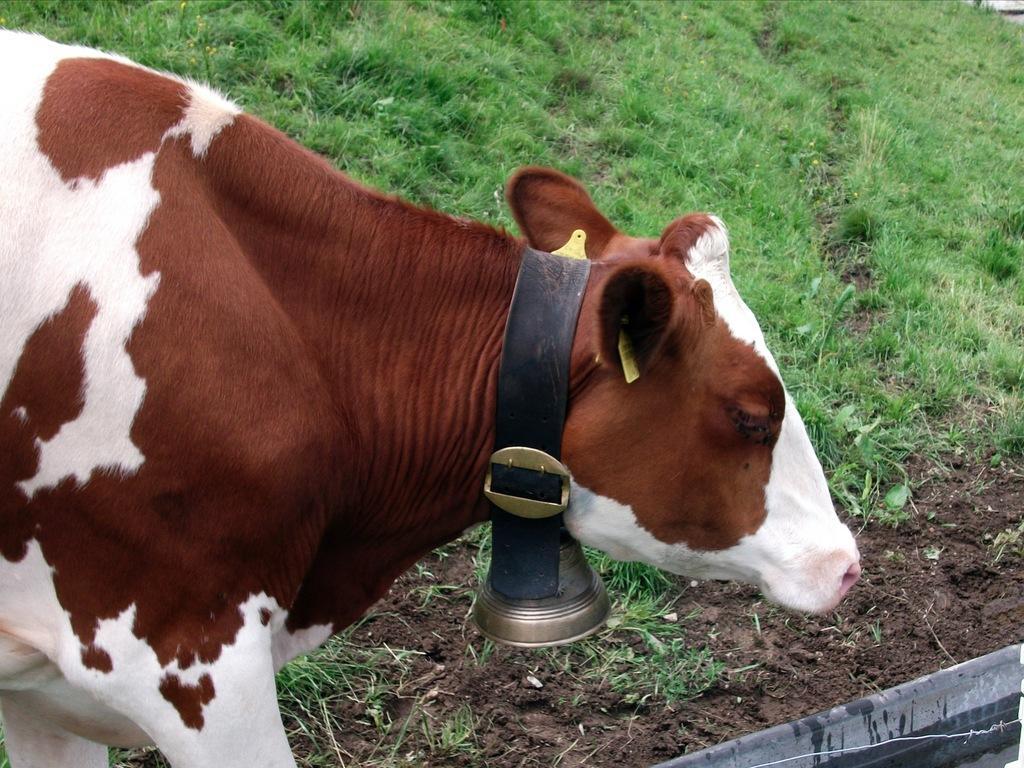Could you give a brief overview of what you see in this image? In this image we can see an animal and there is a bell attached to the neck of the animal and we can see the grass on the ground. 